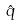<formula> <loc_0><loc_0><loc_500><loc_500>\hat { q }</formula> 